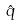<formula> <loc_0><loc_0><loc_500><loc_500>\hat { q }</formula> 